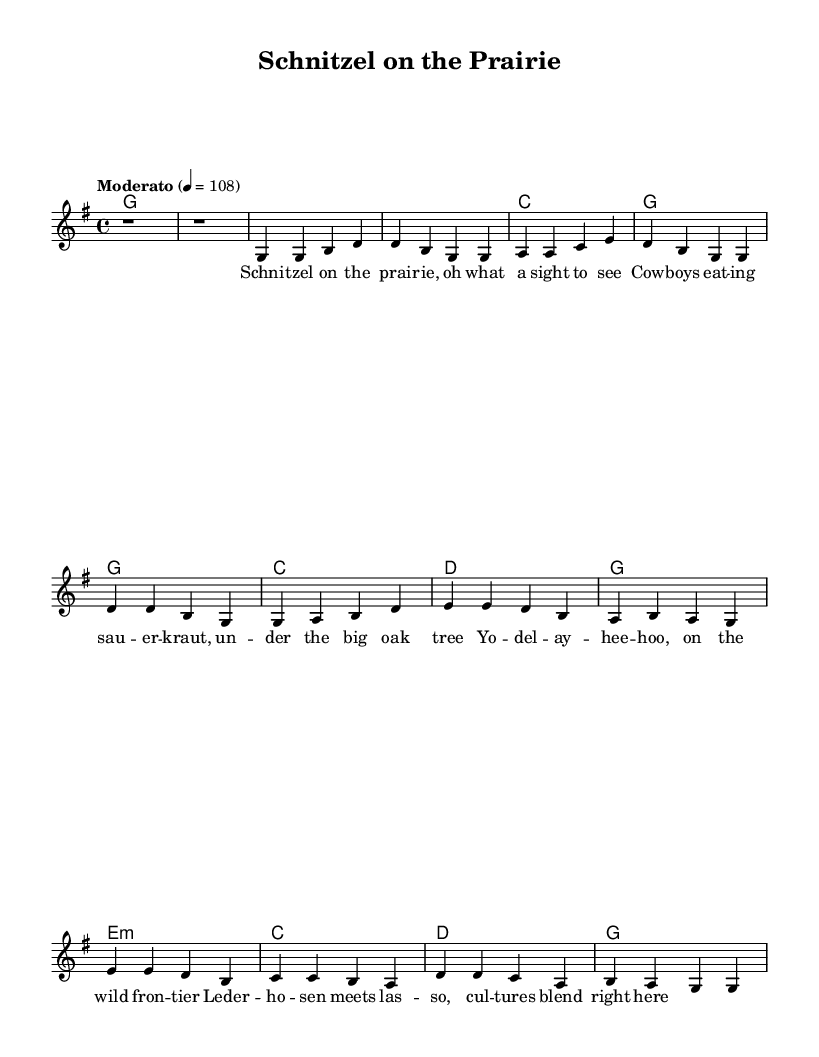What is the key signature of this music? The key signature indicated in the music is G major, which has one sharp (F#). This can be determined by looking at the key signature symbol at the beginning of the staff.
Answer: G major What is the time signature of the piece? The time signature shown at the beginning of the music is 4/4, which is indicated by the numbers placed before the notes. This means there are four beats in each measure.
Answer: 4/4 What is the tempo marking for this piece? The tempo marking is "Moderato," which instructs the performer to play at a moderate speed. This is mentioned right before the tempo indication "4 = 108," specifying the beats per minute.
Answer: Moderato How many beats are in the intro? The intro consists of two measures of rest, with each measure having one whole note rest, totaling two beats in each measure. Therefore, there are 2 beats in the intro.
Answer: 2 What do the lyrics in the chorus describe? The lyrics of the chorus mention merging cultures, specifically referencing traditional German elements like "Lederhosen" (leather trousers) and "laso," showcasing a mixture of influences in the song. This thematic blending is typical for Country Rock songs.
Answer: Cultures blend What is the name of the composition? The title of the composition is clearly indicated at the top of the sheet music as "Schnitzel on the Prairie." This title reflects the fusion aspect of combining country rock with German culture.
Answer: Schnitzel on the Prairie What type of harmony is used in the bridge? In the bridge, the chords are indicated as e minor, c major, d major, and g major. The use of e minor suggests a shift to a more melancholic sound compared to the verses and chorus. This type of harmonic change is common in country rock.
Answer: e minor 